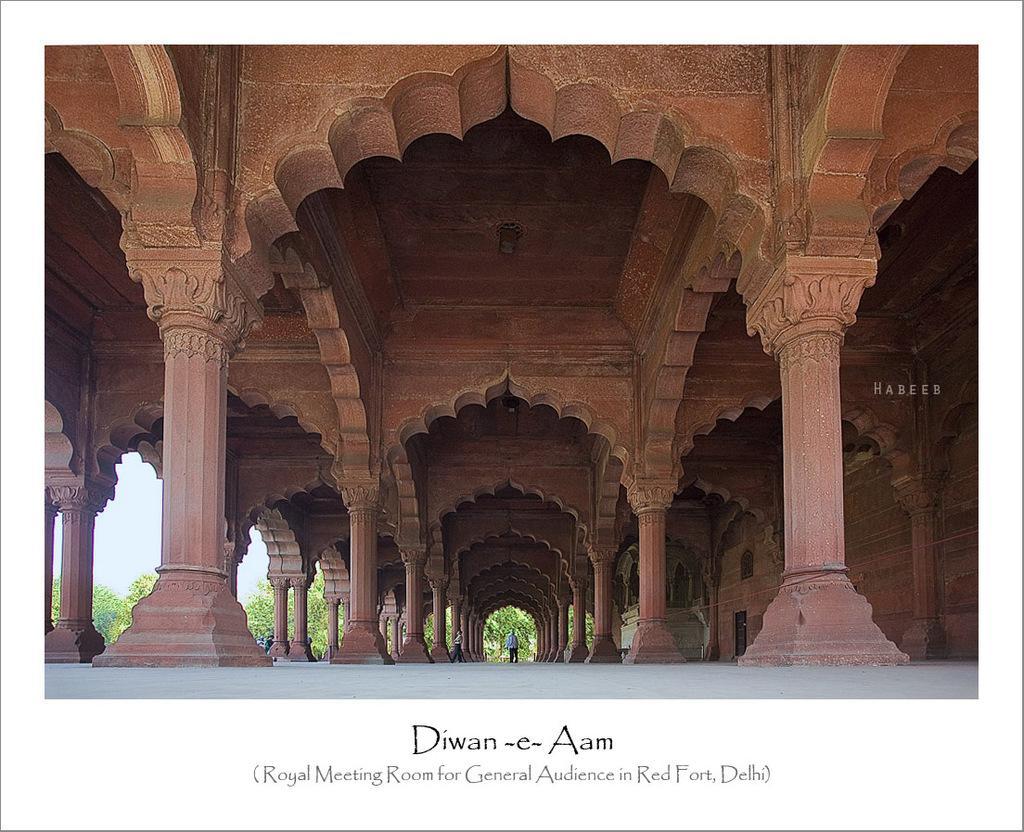In one or two sentences, can you explain what this image depicts? In this image, It looks like a poster. I think this is the inside view of red fort. Here is a person standing. These are the pillars and the arch´s. This is the watermark on the image. I can see the letters on the poster. These are the trees. 